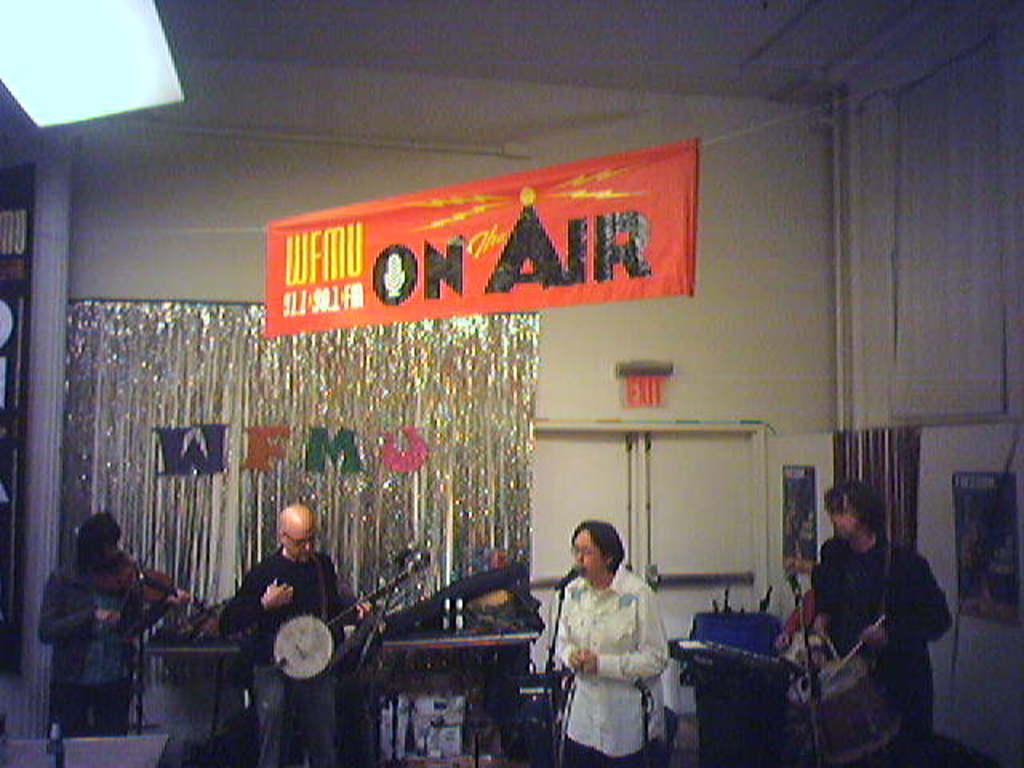How would you summarize this image in a sentence or two? In this image I can see few people standing and holding musical instruments. I can see mics,stands,doors and a white wall. I can see an orange banner. 